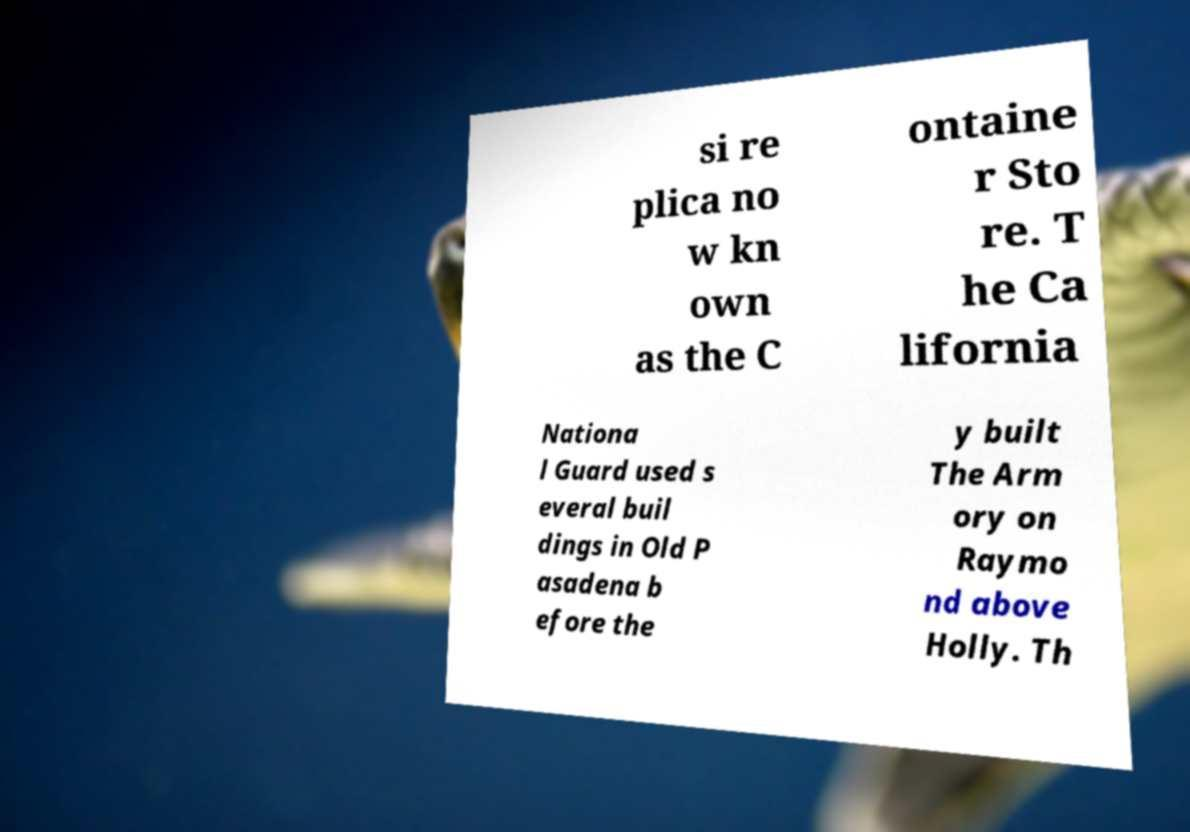Could you extract and type out the text from this image? si re plica no w kn own as the C ontaine r Sto re. T he Ca lifornia Nationa l Guard used s everal buil dings in Old P asadena b efore the y built The Arm ory on Raymo nd above Holly. Th 